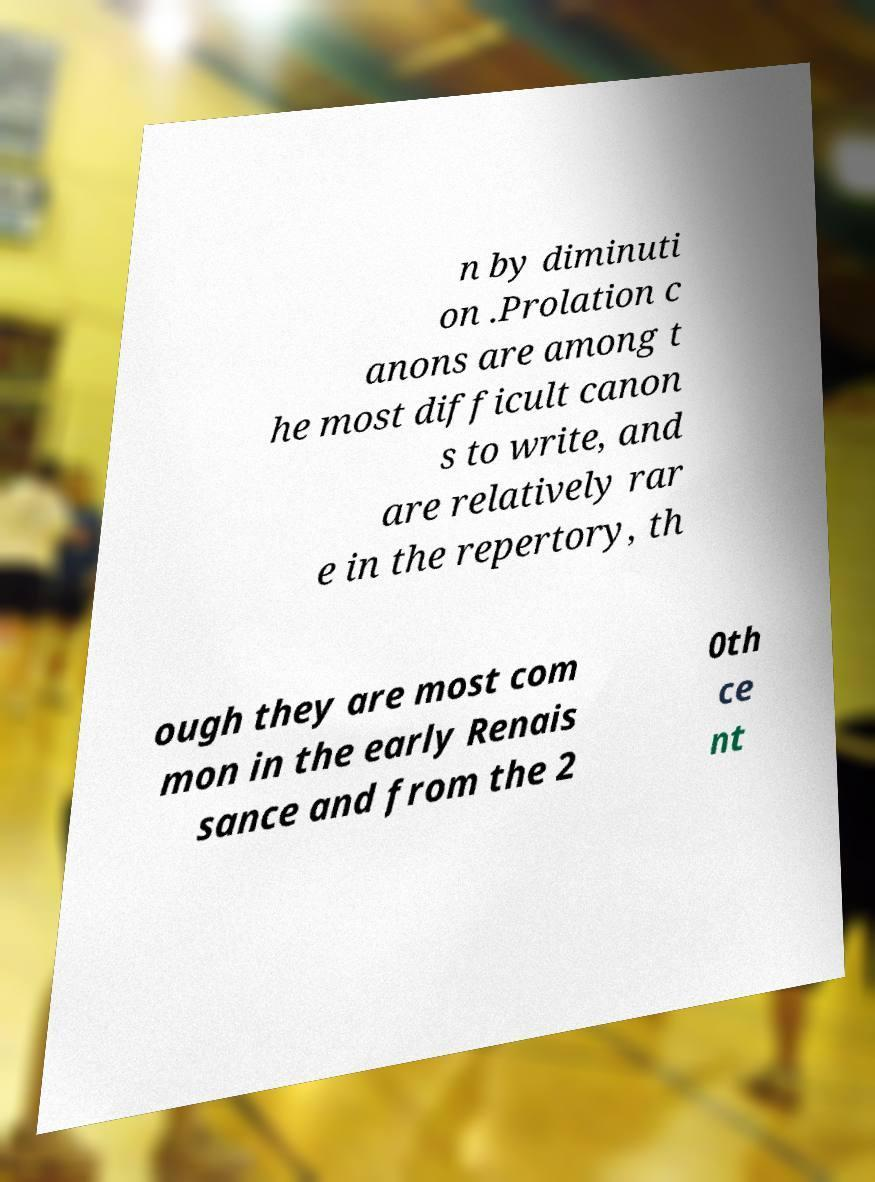Can you accurately transcribe the text from the provided image for me? n by diminuti on .Prolation c anons are among t he most difficult canon s to write, and are relatively rar e in the repertory, th ough they are most com mon in the early Renais sance and from the 2 0th ce nt 